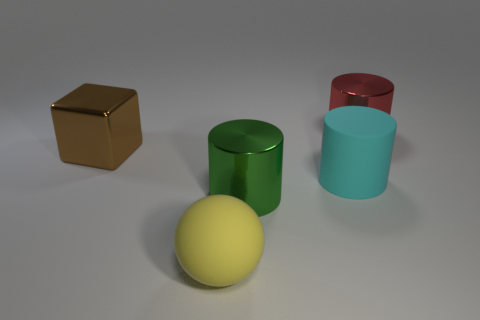How many things are either matte objects behind the yellow sphere or cylinders that are in front of the big red cylinder? There is one matte object, which is a brown cube, located behind the yellow sphere. There are no cylinders in front of the big red cylinder. So, the total number of things that meet the criteria is 1. 